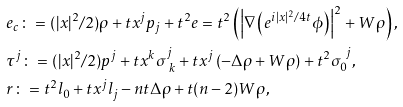<formula> <loc_0><loc_0><loc_500><loc_500>& e _ { c } \colon = ( | x | ^ { 2 } / 2 ) \rho + t x ^ { j } p _ { j } + t ^ { 2 } e = t ^ { 2 } \left ( \left | \nabla \left ( e ^ { i | x | ^ { 2 } / 4 t } \phi \right ) \right | ^ { 2 } + W \rho \right ) , \\ & \tau ^ { j } \colon = ( | x | ^ { 2 } / 2 ) p ^ { j } + t x ^ { k } \sigma ^ { j } _ { \ k } + t x ^ { j } \left ( - \Delta \rho + W \rho \right ) + t ^ { 2 } \sigma _ { 0 } ^ { \ j } , \\ & r \colon = t ^ { 2 } l _ { 0 } + t x ^ { j } l _ { j } - n t \Delta \rho + t ( n - 2 ) W \rho ,</formula> 